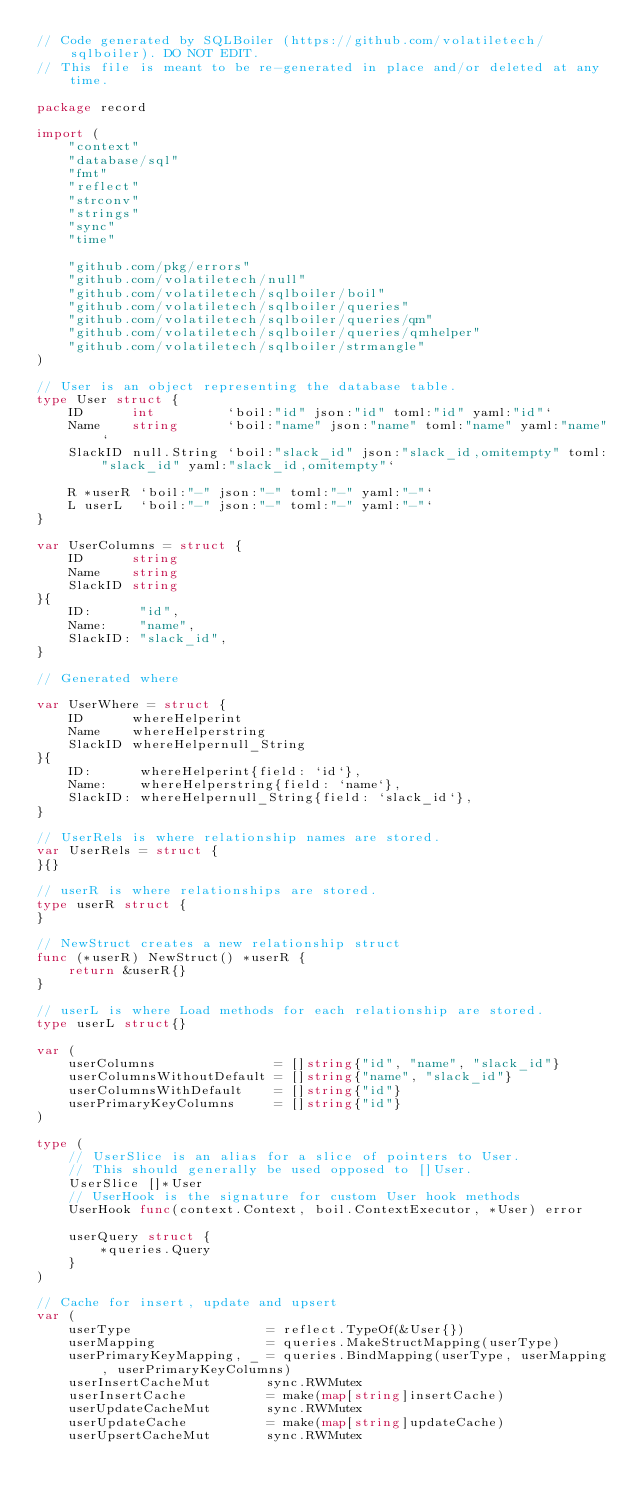Convert code to text. <code><loc_0><loc_0><loc_500><loc_500><_Go_>// Code generated by SQLBoiler (https://github.com/volatiletech/sqlboiler). DO NOT EDIT.
// This file is meant to be re-generated in place and/or deleted at any time.

package record

import (
	"context"
	"database/sql"
	"fmt"
	"reflect"
	"strconv"
	"strings"
	"sync"
	"time"

	"github.com/pkg/errors"
	"github.com/volatiletech/null"
	"github.com/volatiletech/sqlboiler/boil"
	"github.com/volatiletech/sqlboiler/queries"
	"github.com/volatiletech/sqlboiler/queries/qm"
	"github.com/volatiletech/sqlboiler/queries/qmhelper"
	"github.com/volatiletech/sqlboiler/strmangle"
)

// User is an object representing the database table.
type User struct {
	ID      int         `boil:"id" json:"id" toml:"id" yaml:"id"`
	Name    string      `boil:"name" json:"name" toml:"name" yaml:"name"`
	SlackID null.String `boil:"slack_id" json:"slack_id,omitempty" toml:"slack_id" yaml:"slack_id,omitempty"`

	R *userR `boil:"-" json:"-" toml:"-" yaml:"-"`
	L userL  `boil:"-" json:"-" toml:"-" yaml:"-"`
}

var UserColumns = struct {
	ID      string
	Name    string
	SlackID string
}{
	ID:      "id",
	Name:    "name",
	SlackID: "slack_id",
}

// Generated where

var UserWhere = struct {
	ID      whereHelperint
	Name    whereHelperstring
	SlackID whereHelpernull_String
}{
	ID:      whereHelperint{field: `id`},
	Name:    whereHelperstring{field: `name`},
	SlackID: whereHelpernull_String{field: `slack_id`},
}

// UserRels is where relationship names are stored.
var UserRels = struct {
}{}

// userR is where relationships are stored.
type userR struct {
}

// NewStruct creates a new relationship struct
func (*userR) NewStruct() *userR {
	return &userR{}
}

// userL is where Load methods for each relationship are stored.
type userL struct{}

var (
	userColumns               = []string{"id", "name", "slack_id"}
	userColumnsWithoutDefault = []string{"name", "slack_id"}
	userColumnsWithDefault    = []string{"id"}
	userPrimaryKeyColumns     = []string{"id"}
)

type (
	// UserSlice is an alias for a slice of pointers to User.
	// This should generally be used opposed to []User.
	UserSlice []*User
	// UserHook is the signature for custom User hook methods
	UserHook func(context.Context, boil.ContextExecutor, *User) error

	userQuery struct {
		*queries.Query
	}
)

// Cache for insert, update and upsert
var (
	userType                 = reflect.TypeOf(&User{})
	userMapping              = queries.MakeStructMapping(userType)
	userPrimaryKeyMapping, _ = queries.BindMapping(userType, userMapping, userPrimaryKeyColumns)
	userInsertCacheMut       sync.RWMutex
	userInsertCache          = make(map[string]insertCache)
	userUpdateCacheMut       sync.RWMutex
	userUpdateCache          = make(map[string]updateCache)
	userUpsertCacheMut       sync.RWMutex</code> 